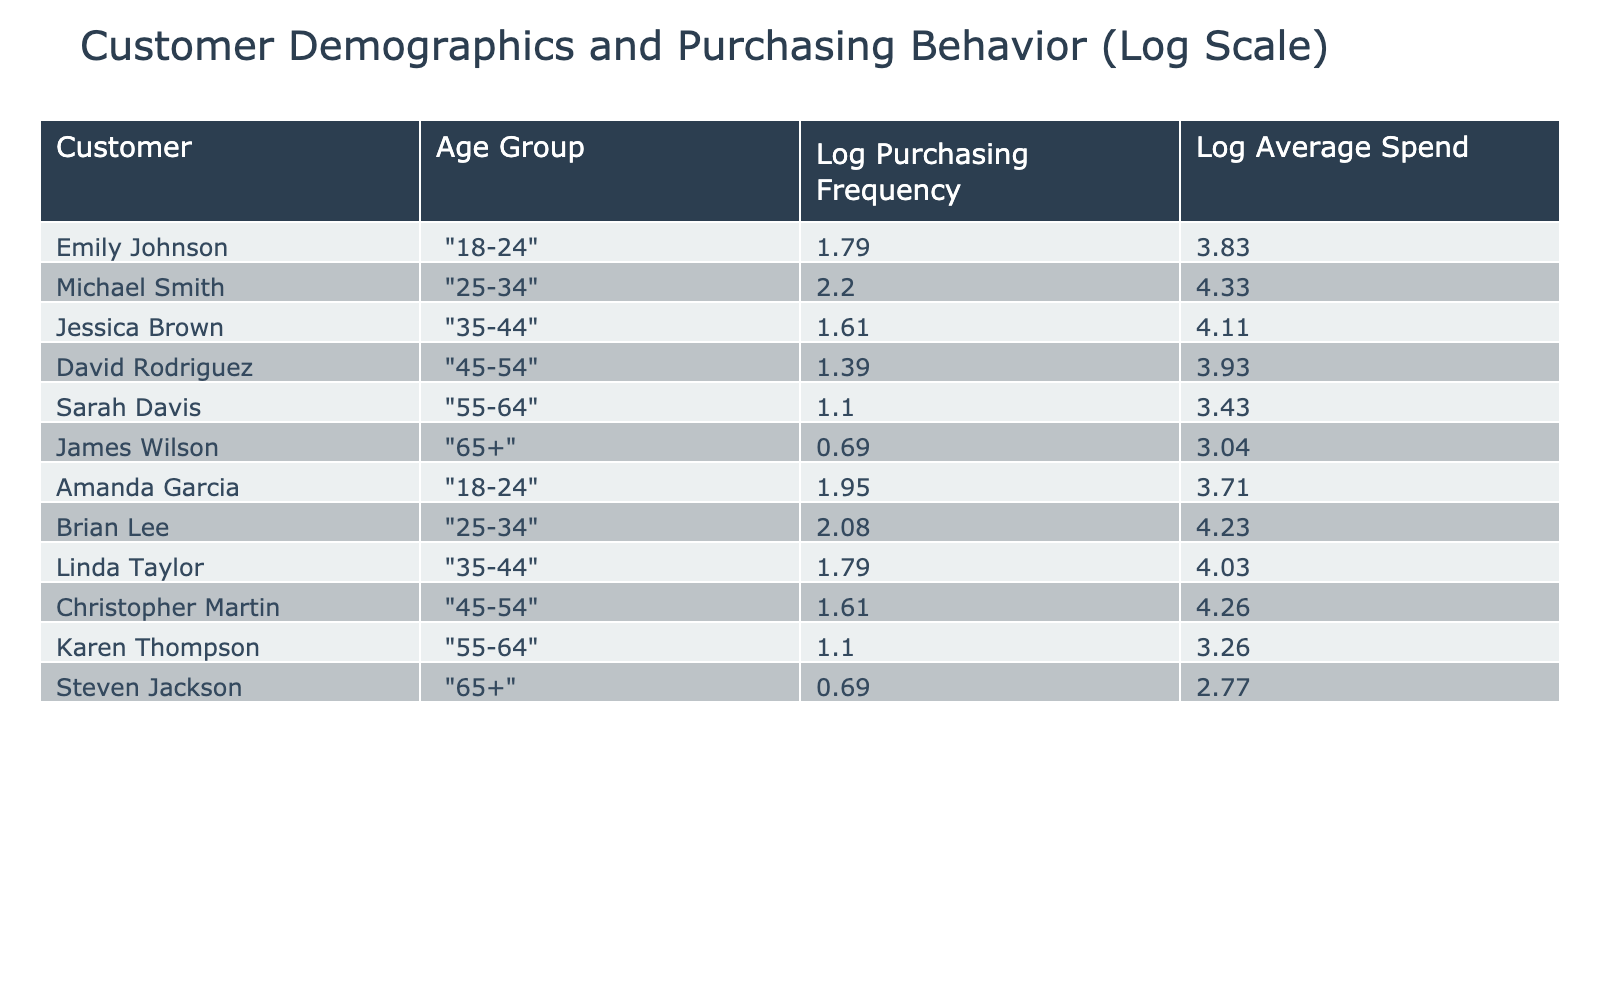What is the log average spend for Emily Johnson? According to the table, the log of the average spend per visit for Emily Johnson is obtained from the row associated with her name. The values tell us her average spend is 45.00, and after applying the logarithmic transformation, it becomes log(45.00 + 1) = 3.81 when rounded to two decimal places.
Answer: 3.81 Which age group has the highest log purchasing frequency? By examining the log purchasing frequency values, we identify the row with the maximum value. Michael Smith from the 25-34 age group has the highest purchasing frequency at 8, resulting in a log of 2.08. Thus, 25-34 is the age group with the highest log purchasing frequency.
Answer: 25-34 What is the total log average spend for customers aged 55-64? First, we look for customers in the 55-64 age group. There are two: Sarah Davis and Karen Thompson with log spends of 3.40 and 3.25 respectively. We then sum these logs: 3.40 + 3.25 = 6.65. Therefore, the total log average spend for this age group is 6.65.
Answer: 6.65 Is the log purchasing frequency for James Wilson higher than that for David Rodriguez? James Wilson has a log purchasing frequency of 0.00 (as he only purchases once), whereas David Rodriguez has a log purchasing frequency of 1.10. Thus, the statement is false, as James Wilson's frequency is lower than David Rodriguez's.
Answer: No What is the average log purchasing frequency for the age group 35-44? There are two individuals in this age group: Jessica Brown (log frequency of 1.39) and Linda Taylor (log frequency of 1.61). Adding them together gives 1.39 + 1.61 = 3.00. Finally, we divide by 2 (since there are 2 customers) to get an average of 1.50.
Answer: 1.50 